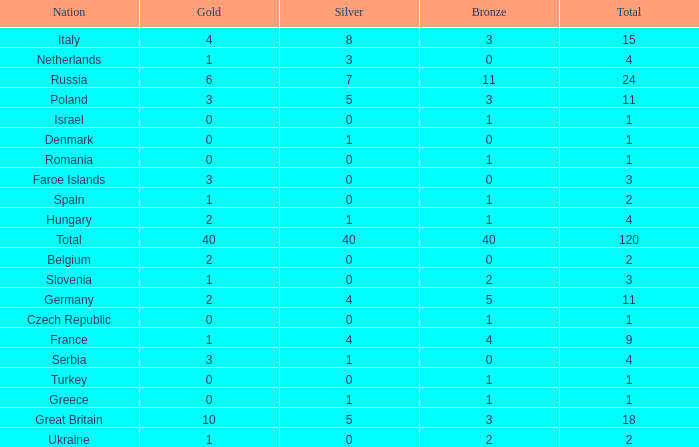What is the average Gold entry for the Netherlands that also has a Bronze entry that is greater than 0? None. 